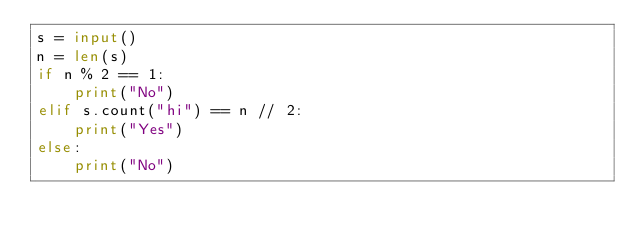<code> <loc_0><loc_0><loc_500><loc_500><_Python_>s = input()
n = len(s)
if n % 2 == 1:
    print("No")
elif s.count("hi") == n // 2:
    print("Yes")
else:
    print("No")</code> 